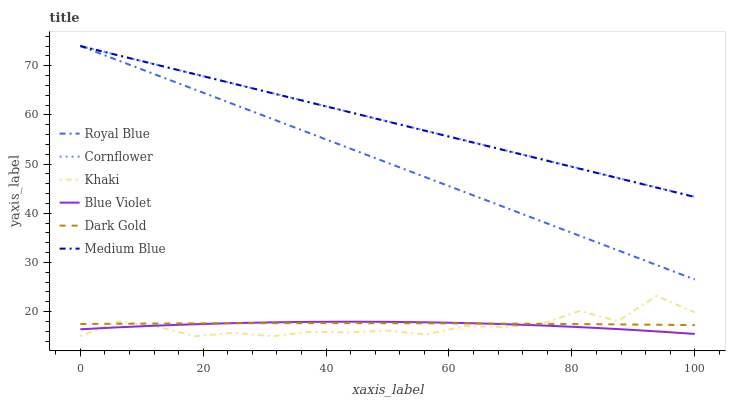Does Khaki have the minimum area under the curve?
Answer yes or no. Yes. Does Cornflower have the maximum area under the curve?
Answer yes or no. Yes. Does Dark Gold have the minimum area under the curve?
Answer yes or no. No. Does Dark Gold have the maximum area under the curve?
Answer yes or no. No. Is Medium Blue the smoothest?
Answer yes or no. Yes. Is Khaki the roughest?
Answer yes or no. Yes. Is Dark Gold the smoothest?
Answer yes or no. No. Is Dark Gold the roughest?
Answer yes or no. No. Does Khaki have the lowest value?
Answer yes or no. Yes. Does Dark Gold have the lowest value?
Answer yes or no. No. Does Royal Blue have the highest value?
Answer yes or no. Yes. Does Khaki have the highest value?
Answer yes or no. No. Is Blue Violet less than Cornflower?
Answer yes or no. Yes. Is Medium Blue greater than Blue Violet?
Answer yes or no. Yes. Does Medium Blue intersect Royal Blue?
Answer yes or no. Yes. Is Medium Blue less than Royal Blue?
Answer yes or no. No. Is Medium Blue greater than Royal Blue?
Answer yes or no. No. Does Blue Violet intersect Cornflower?
Answer yes or no. No. 